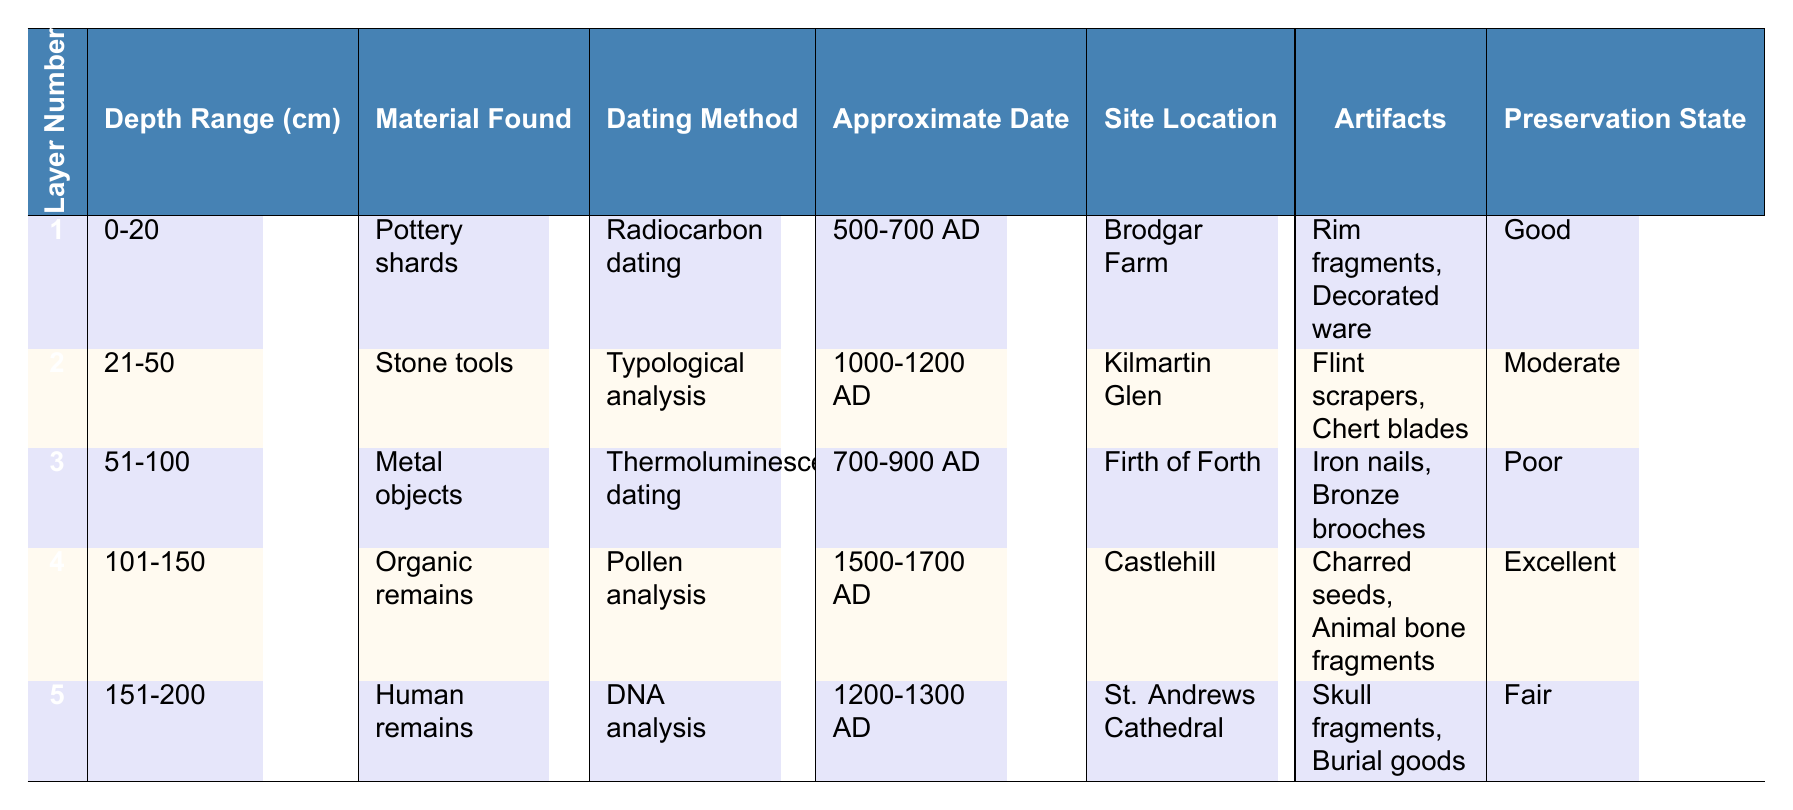What material was found in layer number 1? Layer number 1 corresponds to the row detailing the first layer in the table, which states that the material found is "Pottery shards."
Answer: Pottery shards Which site location has the approximate date of 1500-1700 AD? The table shows that the site location corresponding to that date range is "Castlehill" in layer number 4.
Answer: Castlehill What is the preservation state of the artifacts found in layer 3? According to the table, the preservation state listed for layer number 3 is "Poor" for the metal objects found.
Answer: Poor Is there any evidence of organic remains in the layers? Looking at the table, layer number 4 specifically mentions "Organic remains" as the material found, indicating that yes, there is evidence.
Answer: Yes What is the difference in depth range between the first and fifth layers? The depth range for layer 1 is "0-20 cm" and for layer 5 is "151-200 cm." The difference can be calculated as 200 - 0 = 200 cm, giving us the total depth range difference.
Answer: 200 cm List the different types of artifacts present in layer number 2. In layer number 2, the table indicates that the artifacts found are "Flint scrapers" and "Chert blades."
Answer: Flint scrapers, Chert blades What dating method was used for the human remains found in layer 5? Looking at layer number 5, it states that the dating method used for the human remains is "DNA analysis."
Answer: DNA analysis Which layer contains the earliest artifacts based on the approximate date? By reviewing the approximate dates listed, layer number 1 has artifacts dating from 500-700 AD, making it the earliest layer found in the table.
Answer: Layer 1 How many different sites are represented in the table? The table reveals the following unique site locations: Brodgar Farm, Kilmartin Glen, Firth of Forth, Castlehill, and St. Andrews Cathedral, totaling 5 different sites.
Answer: 5 